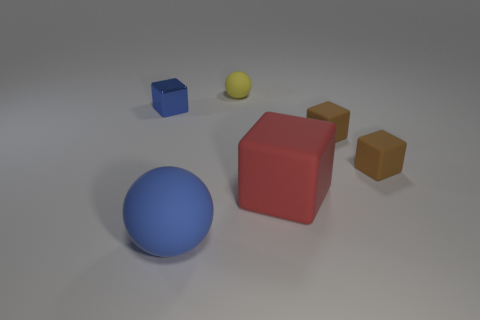Subtract all tiny blocks. How many blocks are left? 1 Add 1 tiny blue cubes. How many objects exist? 7 Subtract all blue blocks. How many blocks are left? 3 Subtract all blocks. How many objects are left? 2 Subtract 1 balls. How many balls are left? 1 Add 2 red things. How many red things exist? 3 Subtract 1 blue blocks. How many objects are left? 5 Subtract all purple cubes. Subtract all purple cylinders. How many cubes are left? 4 Subtract all yellow balls. How many brown blocks are left? 2 Subtract all small things. Subtract all big blue spheres. How many objects are left? 1 